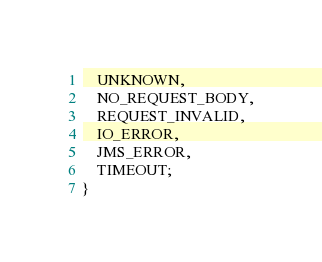Convert code to text. <code><loc_0><loc_0><loc_500><loc_500><_Java_>	UNKNOWN,
	NO_REQUEST_BODY,
	REQUEST_INVALID,
	IO_ERROR,
	JMS_ERROR,
	TIMEOUT;
}
</code> 